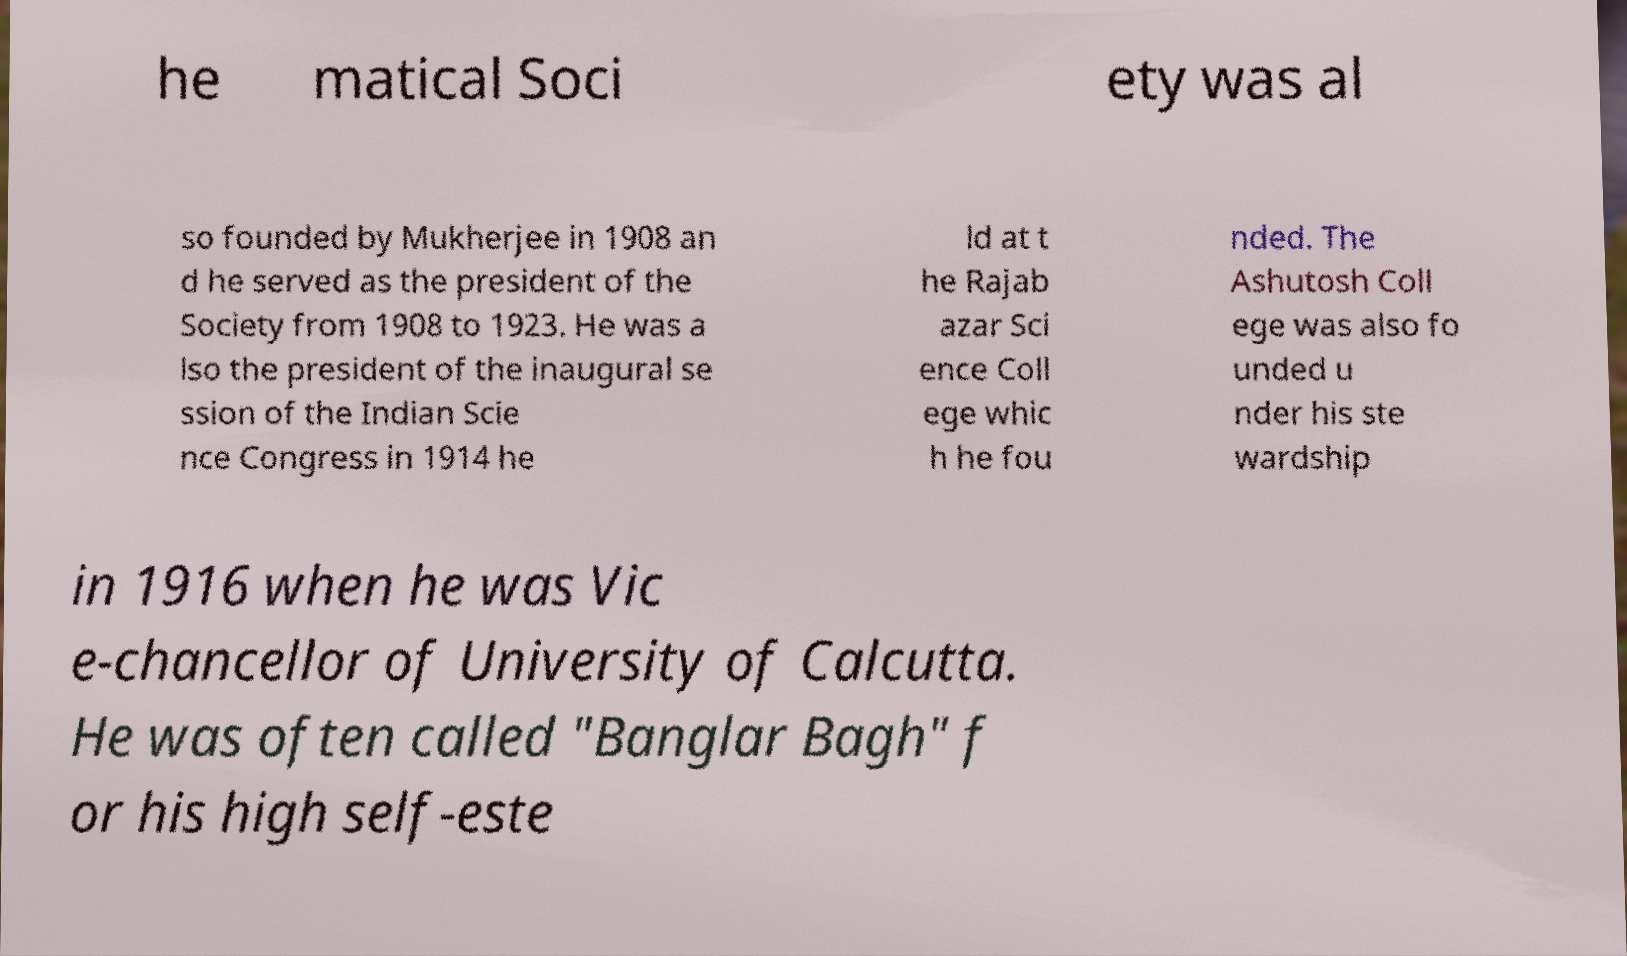I need the written content from this picture converted into text. Can you do that? he matical Soci ety was al so founded by Mukherjee in 1908 an d he served as the president of the Society from 1908 to 1923. He was a lso the president of the inaugural se ssion of the Indian Scie nce Congress in 1914 he ld at t he Rajab azar Sci ence Coll ege whic h he fou nded. The Ashutosh Coll ege was also fo unded u nder his ste wardship in 1916 when he was Vic e-chancellor of University of Calcutta. He was often called "Banglar Bagh" f or his high self-este 